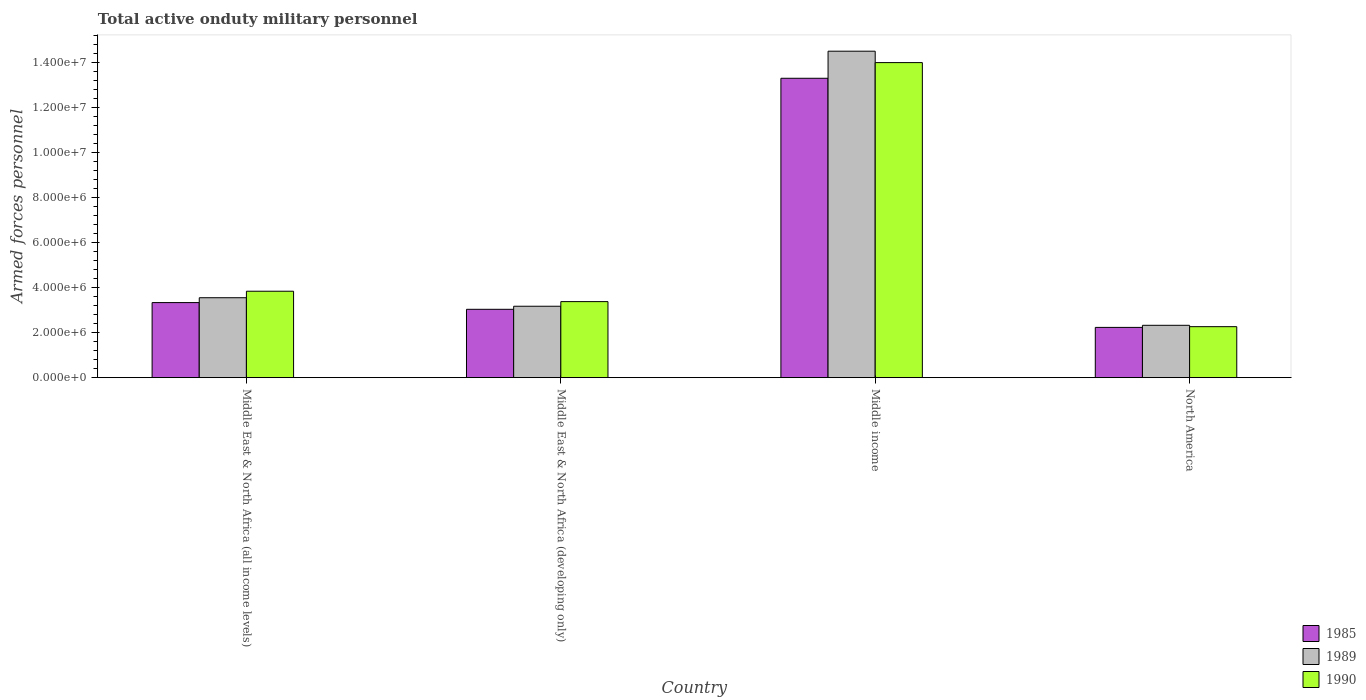How many different coloured bars are there?
Provide a short and direct response. 3. Are the number of bars per tick equal to the number of legend labels?
Ensure brevity in your answer.  Yes. Are the number of bars on each tick of the X-axis equal?
Your answer should be compact. Yes. How many bars are there on the 3rd tick from the left?
Keep it short and to the point. 3. What is the label of the 3rd group of bars from the left?
Your response must be concise. Middle income. In how many cases, is the number of bars for a given country not equal to the number of legend labels?
Provide a succinct answer. 0. What is the number of armed forces personnel in 1985 in North America?
Provide a succinct answer. 2.23e+06. Across all countries, what is the maximum number of armed forces personnel in 1989?
Your response must be concise. 1.45e+07. Across all countries, what is the minimum number of armed forces personnel in 1985?
Your answer should be very brief. 2.23e+06. In which country was the number of armed forces personnel in 1990 maximum?
Make the answer very short. Middle income. What is the total number of armed forces personnel in 1985 in the graph?
Your response must be concise. 2.19e+07. What is the difference between the number of armed forces personnel in 1989 in Middle East & North Africa (developing only) and that in North America?
Provide a succinct answer. 8.47e+05. What is the difference between the number of armed forces personnel in 1989 in Middle East & North Africa (all income levels) and the number of armed forces personnel in 1990 in Middle income?
Offer a terse response. -1.05e+07. What is the average number of armed forces personnel in 1985 per country?
Make the answer very short. 5.48e+06. What is the difference between the number of armed forces personnel of/in 1990 and number of armed forces personnel of/in 1985 in Middle East & North Africa (developing only)?
Offer a very short reply. 3.42e+05. In how many countries, is the number of armed forces personnel in 1989 greater than 12000000?
Give a very brief answer. 1. What is the ratio of the number of armed forces personnel in 1985 in Middle East & North Africa (all income levels) to that in North America?
Give a very brief answer. 1.49. Is the number of armed forces personnel in 1985 in Middle income less than that in North America?
Ensure brevity in your answer.  No. What is the difference between the highest and the second highest number of armed forces personnel in 1990?
Your response must be concise. 1.06e+07. What is the difference between the highest and the lowest number of armed forces personnel in 1989?
Offer a terse response. 1.22e+07. Is the sum of the number of armed forces personnel in 1989 in Middle East & North Africa (developing only) and Middle income greater than the maximum number of armed forces personnel in 1990 across all countries?
Make the answer very short. Yes. What is the difference between two consecutive major ticks on the Y-axis?
Offer a terse response. 2.00e+06. Does the graph contain grids?
Offer a terse response. No. What is the title of the graph?
Offer a terse response. Total active onduty military personnel. What is the label or title of the Y-axis?
Provide a short and direct response. Armed forces personnel. What is the Armed forces personnel of 1985 in Middle East & North Africa (all income levels)?
Give a very brief answer. 3.34e+06. What is the Armed forces personnel in 1989 in Middle East & North Africa (all income levels)?
Make the answer very short. 3.55e+06. What is the Armed forces personnel of 1990 in Middle East & North Africa (all income levels)?
Keep it short and to the point. 3.84e+06. What is the Armed forces personnel of 1985 in Middle East & North Africa (developing only)?
Your answer should be compact. 3.04e+06. What is the Armed forces personnel of 1989 in Middle East & North Africa (developing only)?
Offer a terse response. 3.18e+06. What is the Armed forces personnel of 1990 in Middle East & North Africa (developing only)?
Your answer should be very brief. 3.38e+06. What is the Armed forces personnel in 1985 in Middle income?
Ensure brevity in your answer.  1.33e+07. What is the Armed forces personnel of 1989 in Middle income?
Provide a succinct answer. 1.45e+07. What is the Armed forces personnel of 1990 in Middle income?
Offer a very short reply. 1.40e+07. What is the Armed forces personnel in 1985 in North America?
Give a very brief answer. 2.23e+06. What is the Armed forces personnel of 1989 in North America?
Your answer should be very brief. 2.33e+06. What is the Armed forces personnel in 1990 in North America?
Provide a short and direct response. 2.27e+06. Across all countries, what is the maximum Armed forces personnel in 1985?
Offer a terse response. 1.33e+07. Across all countries, what is the maximum Armed forces personnel of 1989?
Your response must be concise. 1.45e+07. Across all countries, what is the maximum Armed forces personnel in 1990?
Your answer should be very brief. 1.40e+07. Across all countries, what is the minimum Armed forces personnel of 1985?
Make the answer very short. 2.23e+06. Across all countries, what is the minimum Armed forces personnel in 1989?
Make the answer very short. 2.33e+06. Across all countries, what is the minimum Armed forces personnel of 1990?
Offer a terse response. 2.27e+06. What is the total Armed forces personnel in 1985 in the graph?
Provide a short and direct response. 2.19e+07. What is the total Armed forces personnel in 1989 in the graph?
Provide a short and direct response. 2.36e+07. What is the total Armed forces personnel of 1990 in the graph?
Provide a short and direct response. 2.35e+07. What is the difference between the Armed forces personnel of 1985 in Middle East & North Africa (all income levels) and that in Middle East & North Africa (developing only)?
Your response must be concise. 2.98e+05. What is the difference between the Armed forces personnel of 1989 in Middle East & North Africa (all income levels) and that in Middle East & North Africa (developing only)?
Provide a short and direct response. 3.79e+05. What is the difference between the Armed forces personnel of 1990 in Middle East & North Africa (all income levels) and that in Middle East & North Africa (developing only)?
Offer a very short reply. 4.62e+05. What is the difference between the Armed forces personnel in 1985 in Middle East & North Africa (all income levels) and that in Middle income?
Offer a terse response. -9.97e+06. What is the difference between the Armed forces personnel in 1989 in Middle East & North Africa (all income levels) and that in Middle income?
Provide a succinct answer. -1.10e+07. What is the difference between the Armed forces personnel of 1990 in Middle East & North Africa (all income levels) and that in Middle income?
Offer a terse response. -1.02e+07. What is the difference between the Armed forces personnel of 1985 in Middle East & North Africa (all income levels) and that in North America?
Provide a succinct answer. 1.10e+06. What is the difference between the Armed forces personnel in 1989 in Middle East & North Africa (all income levels) and that in North America?
Ensure brevity in your answer.  1.23e+06. What is the difference between the Armed forces personnel in 1990 in Middle East & North Africa (all income levels) and that in North America?
Keep it short and to the point. 1.58e+06. What is the difference between the Armed forces personnel of 1985 in Middle East & North Africa (developing only) and that in Middle income?
Keep it short and to the point. -1.03e+07. What is the difference between the Armed forces personnel of 1989 in Middle East & North Africa (developing only) and that in Middle income?
Give a very brief answer. -1.13e+07. What is the difference between the Armed forces personnel of 1990 in Middle East & North Africa (developing only) and that in Middle income?
Provide a short and direct response. -1.06e+07. What is the difference between the Armed forces personnel in 1985 in Middle East & North Africa (developing only) and that in North America?
Keep it short and to the point. 8.05e+05. What is the difference between the Armed forces personnel of 1989 in Middle East & North Africa (developing only) and that in North America?
Provide a short and direct response. 8.47e+05. What is the difference between the Armed forces personnel of 1990 in Middle East & North Africa (developing only) and that in North America?
Provide a short and direct response. 1.11e+06. What is the difference between the Armed forces personnel in 1985 in Middle income and that in North America?
Keep it short and to the point. 1.11e+07. What is the difference between the Armed forces personnel in 1989 in Middle income and that in North America?
Your answer should be very brief. 1.22e+07. What is the difference between the Armed forces personnel in 1990 in Middle income and that in North America?
Your response must be concise. 1.17e+07. What is the difference between the Armed forces personnel in 1985 in Middle East & North Africa (all income levels) and the Armed forces personnel in 1989 in Middle East & North Africa (developing only)?
Your response must be concise. 1.63e+05. What is the difference between the Armed forces personnel in 1985 in Middle East & North Africa (all income levels) and the Armed forces personnel in 1990 in Middle East & North Africa (developing only)?
Provide a short and direct response. -4.33e+04. What is the difference between the Armed forces personnel of 1989 in Middle East & North Africa (all income levels) and the Armed forces personnel of 1990 in Middle East & North Africa (developing only)?
Give a very brief answer. 1.73e+05. What is the difference between the Armed forces personnel in 1985 in Middle East & North Africa (all income levels) and the Armed forces personnel in 1989 in Middle income?
Offer a very short reply. -1.12e+07. What is the difference between the Armed forces personnel of 1985 in Middle East & North Africa (all income levels) and the Armed forces personnel of 1990 in Middle income?
Your answer should be compact. -1.07e+07. What is the difference between the Armed forces personnel of 1989 in Middle East & North Africa (all income levels) and the Armed forces personnel of 1990 in Middle income?
Keep it short and to the point. -1.05e+07. What is the difference between the Armed forces personnel in 1985 in Middle East & North Africa (all income levels) and the Armed forces personnel in 1989 in North America?
Your answer should be very brief. 1.01e+06. What is the difference between the Armed forces personnel of 1985 in Middle East & North Africa (all income levels) and the Armed forces personnel of 1990 in North America?
Provide a short and direct response. 1.07e+06. What is the difference between the Armed forces personnel of 1989 in Middle East & North Africa (all income levels) and the Armed forces personnel of 1990 in North America?
Keep it short and to the point. 1.29e+06. What is the difference between the Armed forces personnel of 1985 in Middle East & North Africa (developing only) and the Armed forces personnel of 1989 in Middle income?
Ensure brevity in your answer.  -1.15e+07. What is the difference between the Armed forces personnel in 1985 in Middle East & North Africa (developing only) and the Armed forces personnel in 1990 in Middle income?
Ensure brevity in your answer.  -1.10e+07. What is the difference between the Armed forces personnel of 1989 in Middle East & North Africa (developing only) and the Armed forces personnel of 1990 in Middle income?
Provide a succinct answer. -1.08e+07. What is the difference between the Armed forces personnel in 1985 in Middle East & North Africa (developing only) and the Armed forces personnel in 1989 in North America?
Make the answer very short. 7.11e+05. What is the difference between the Armed forces personnel of 1985 in Middle East & North Africa (developing only) and the Armed forces personnel of 1990 in North America?
Provide a short and direct response. 7.72e+05. What is the difference between the Armed forces personnel of 1989 in Middle East & North Africa (developing only) and the Armed forces personnel of 1990 in North America?
Provide a short and direct response. 9.08e+05. What is the difference between the Armed forces personnel in 1985 in Middle income and the Armed forces personnel in 1989 in North America?
Provide a succinct answer. 1.10e+07. What is the difference between the Armed forces personnel in 1985 in Middle income and the Armed forces personnel in 1990 in North America?
Make the answer very short. 1.10e+07. What is the difference between the Armed forces personnel in 1989 in Middle income and the Armed forces personnel in 1990 in North America?
Offer a terse response. 1.22e+07. What is the average Armed forces personnel of 1985 per country?
Provide a short and direct response. 5.48e+06. What is the average Armed forces personnel of 1989 per country?
Your answer should be compact. 5.89e+06. What is the average Armed forces personnel in 1990 per country?
Give a very brief answer. 5.87e+06. What is the difference between the Armed forces personnel of 1985 and Armed forces personnel of 1989 in Middle East & North Africa (all income levels)?
Provide a succinct answer. -2.16e+05. What is the difference between the Armed forces personnel of 1985 and Armed forces personnel of 1990 in Middle East & North Africa (all income levels)?
Make the answer very short. -5.05e+05. What is the difference between the Armed forces personnel in 1989 and Armed forces personnel in 1990 in Middle East & North Africa (all income levels)?
Offer a terse response. -2.89e+05. What is the difference between the Armed forces personnel in 1985 and Armed forces personnel in 1989 in Middle East & North Africa (developing only)?
Provide a succinct answer. -1.36e+05. What is the difference between the Armed forces personnel of 1985 and Armed forces personnel of 1990 in Middle East & North Africa (developing only)?
Your answer should be compact. -3.42e+05. What is the difference between the Armed forces personnel of 1989 and Armed forces personnel of 1990 in Middle East & North Africa (developing only)?
Offer a terse response. -2.06e+05. What is the difference between the Armed forces personnel in 1985 and Armed forces personnel in 1989 in Middle income?
Your answer should be very brief. -1.20e+06. What is the difference between the Armed forces personnel of 1985 and Armed forces personnel of 1990 in Middle income?
Provide a succinct answer. -6.97e+05. What is the difference between the Armed forces personnel of 1989 and Armed forces personnel of 1990 in Middle income?
Your response must be concise. 5.07e+05. What is the difference between the Armed forces personnel of 1985 and Armed forces personnel of 1989 in North America?
Give a very brief answer. -9.34e+04. What is the difference between the Armed forces personnel in 1985 and Armed forces personnel in 1990 in North America?
Your answer should be very brief. -3.24e+04. What is the difference between the Armed forces personnel of 1989 and Armed forces personnel of 1990 in North America?
Offer a very short reply. 6.10e+04. What is the ratio of the Armed forces personnel of 1985 in Middle East & North Africa (all income levels) to that in Middle East & North Africa (developing only)?
Give a very brief answer. 1.1. What is the ratio of the Armed forces personnel of 1989 in Middle East & North Africa (all income levels) to that in Middle East & North Africa (developing only)?
Ensure brevity in your answer.  1.12. What is the ratio of the Armed forces personnel in 1990 in Middle East & North Africa (all income levels) to that in Middle East & North Africa (developing only)?
Keep it short and to the point. 1.14. What is the ratio of the Armed forces personnel of 1985 in Middle East & North Africa (all income levels) to that in Middle income?
Your response must be concise. 0.25. What is the ratio of the Armed forces personnel in 1989 in Middle East & North Africa (all income levels) to that in Middle income?
Your response must be concise. 0.24. What is the ratio of the Armed forces personnel in 1990 in Middle East & North Africa (all income levels) to that in Middle income?
Give a very brief answer. 0.27. What is the ratio of the Armed forces personnel of 1985 in Middle East & North Africa (all income levels) to that in North America?
Make the answer very short. 1.49. What is the ratio of the Armed forces personnel in 1989 in Middle East & North Africa (all income levels) to that in North America?
Offer a terse response. 1.53. What is the ratio of the Armed forces personnel of 1990 in Middle East & North Africa (all income levels) to that in North America?
Offer a very short reply. 1.7. What is the ratio of the Armed forces personnel of 1985 in Middle East & North Africa (developing only) to that in Middle income?
Provide a short and direct response. 0.23. What is the ratio of the Armed forces personnel in 1989 in Middle East & North Africa (developing only) to that in Middle income?
Give a very brief answer. 0.22. What is the ratio of the Armed forces personnel in 1990 in Middle East & North Africa (developing only) to that in Middle income?
Your answer should be compact. 0.24. What is the ratio of the Armed forces personnel of 1985 in Middle East & North Africa (developing only) to that in North America?
Give a very brief answer. 1.36. What is the ratio of the Armed forces personnel of 1989 in Middle East & North Africa (developing only) to that in North America?
Your response must be concise. 1.36. What is the ratio of the Armed forces personnel in 1990 in Middle East & North Africa (developing only) to that in North America?
Provide a short and direct response. 1.49. What is the ratio of the Armed forces personnel of 1985 in Middle income to that in North America?
Keep it short and to the point. 5.96. What is the ratio of the Armed forces personnel in 1989 in Middle income to that in North America?
Make the answer very short. 6.23. What is the ratio of the Armed forces personnel in 1990 in Middle income to that in North America?
Your response must be concise. 6.18. What is the difference between the highest and the second highest Armed forces personnel of 1985?
Offer a very short reply. 9.97e+06. What is the difference between the highest and the second highest Armed forces personnel of 1989?
Keep it short and to the point. 1.10e+07. What is the difference between the highest and the second highest Armed forces personnel in 1990?
Your response must be concise. 1.02e+07. What is the difference between the highest and the lowest Armed forces personnel of 1985?
Offer a terse response. 1.11e+07. What is the difference between the highest and the lowest Armed forces personnel in 1989?
Ensure brevity in your answer.  1.22e+07. What is the difference between the highest and the lowest Armed forces personnel in 1990?
Provide a short and direct response. 1.17e+07. 